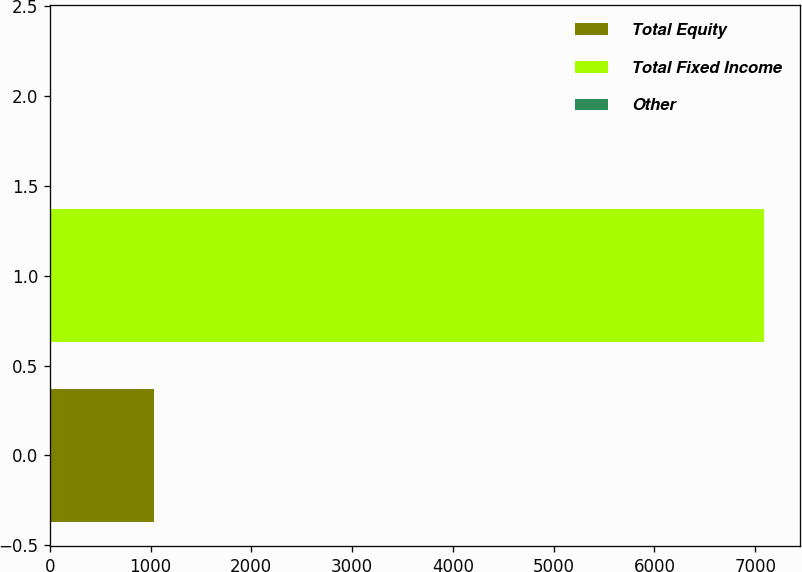Convert chart. <chart><loc_0><loc_0><loc_500><loc_500><bar_chart><fcel>Total Equity<fcel>Total Fixed Income<fcel>Other<nl><fcel>1030<fcel>7090<fcel>10<nl></chart> 